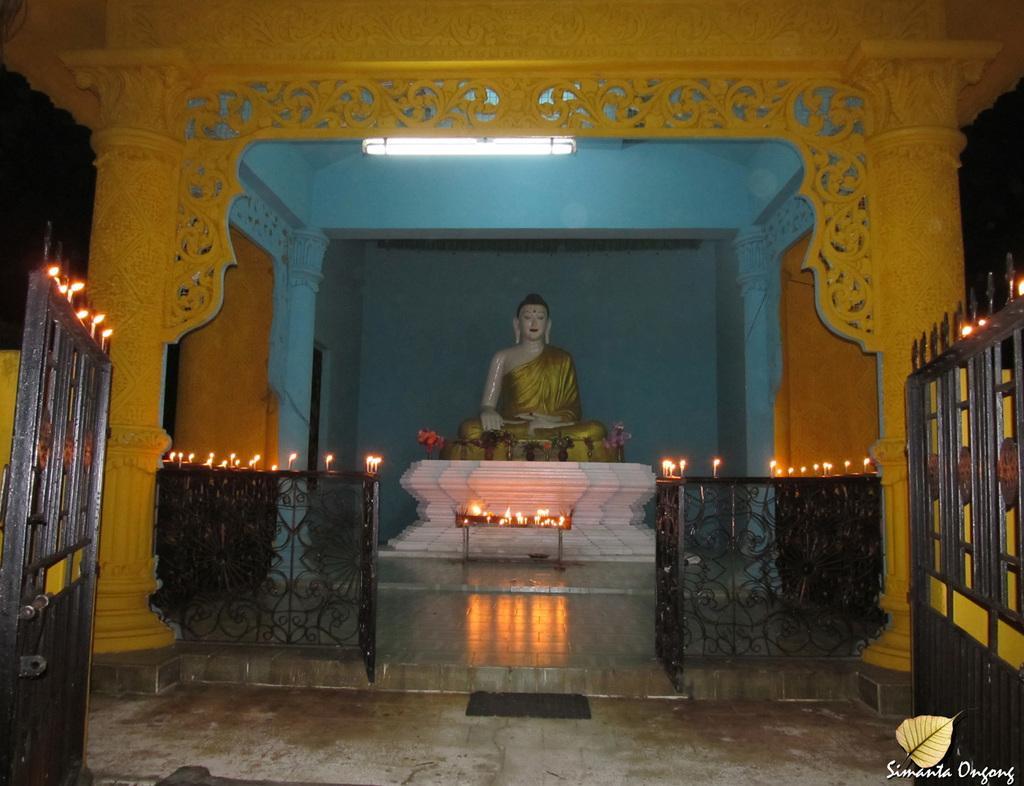In one or two sentences, can you explain what this image depicts? In this image, we can see an arch with Lord Buddha statue on a white surface. We can also see the walls and a light. We can also see the fencing, candles. We can also see the ground. 